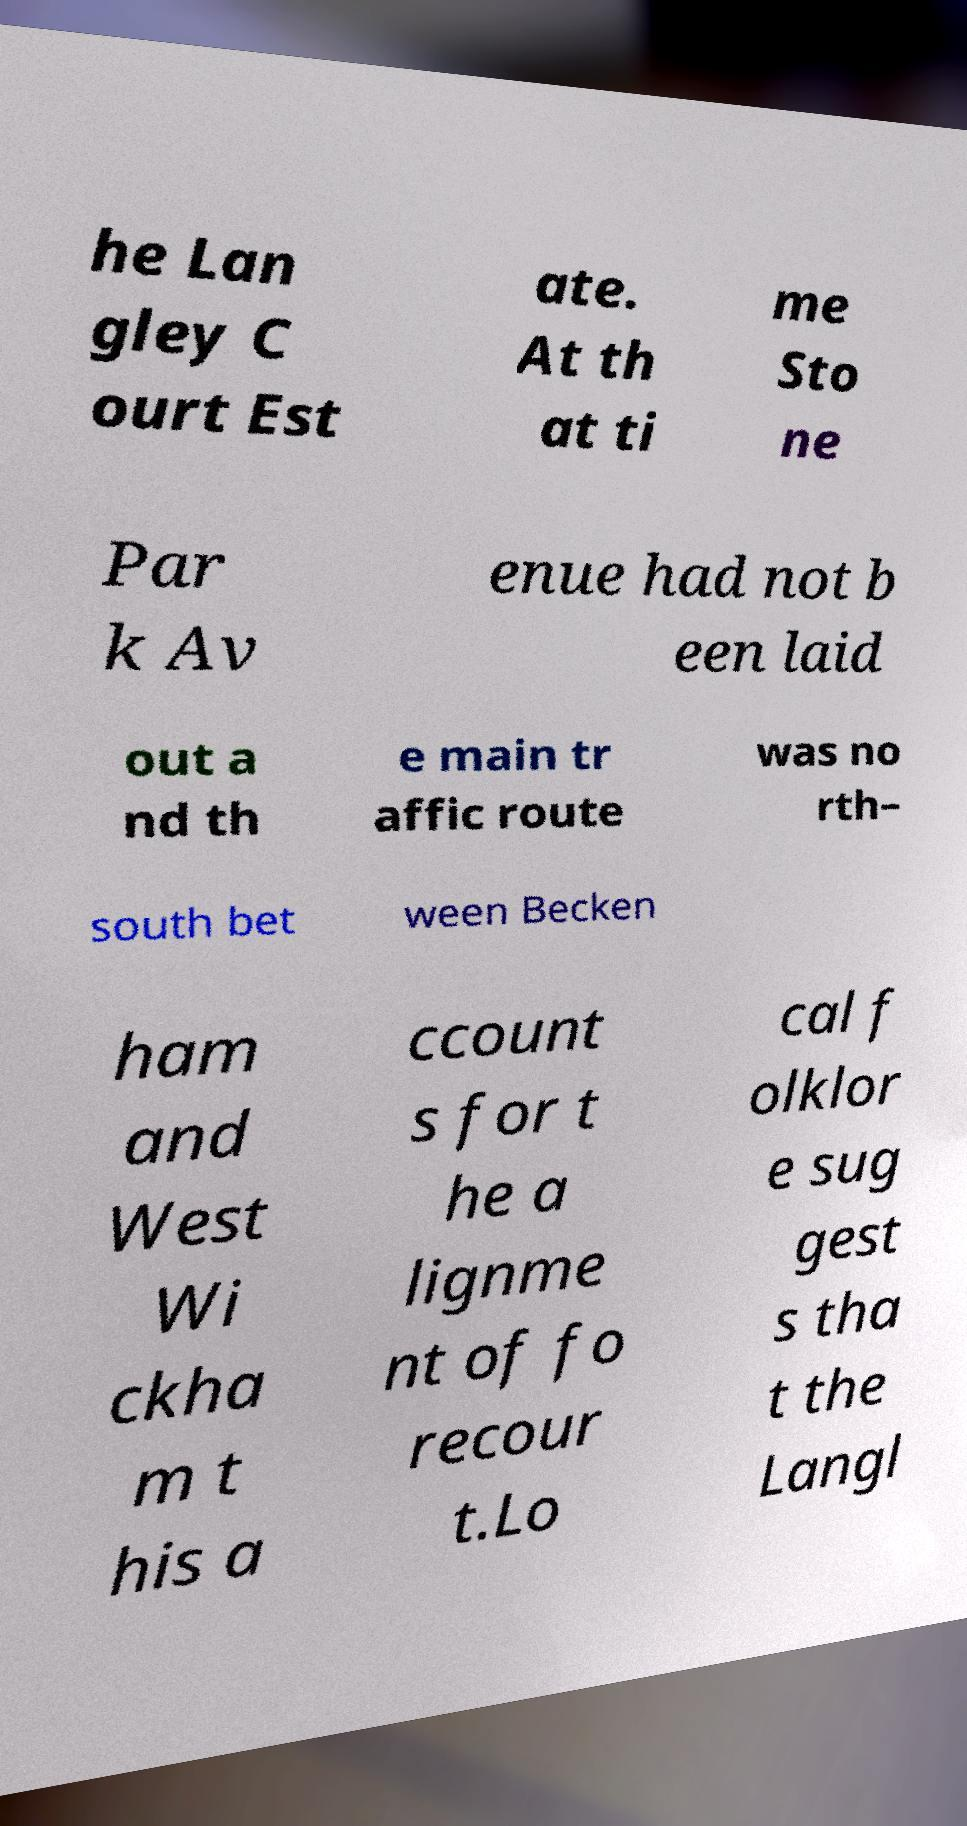Can you read and provide the text displayed in the image?This photo seems to have some interesting text. Can you extract and type it out for me? he Lan gley C ourt Est ate. At th at ti me Sto ne Par k Av enue had not b een laid out a nd th e main tr affic route was no rth– south bet ween Becken ham and West Wi ckha m t his a ccount s for t he a lignme nt of fo recour t.Lo cal f olklor e sug gest s tha t the Langl 